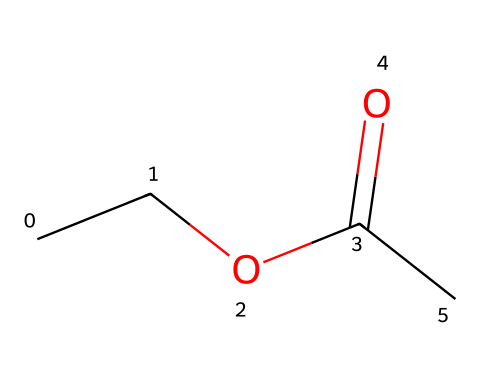what is the molecular formula of this compound? To find the molecular formula, we count the number of each type of atom in the SMILES representation. The structure indicates it contains 4 carbons (C), 8 hydrogens (H), and 2 oxygens (O), resulting in the molecular formula C4H8O2.
Answer: C4H8O2 how many carbon atoms are present in this chemical? By analyzing the SMILES representation, we see the part 'CCOC(=O)C', which includes four 'C' characters. Therefore, there are four carbon atoms in total.
Answer: 4 what type of functional group does this compound contain? The presence of the 'C(=O)' portion indicates a carbonyl functional group. Additionally, the 'C(=O)O' suggests the presence of a carboxylic acid functional group. Thus, this compound is an ester due to the 'COC' linked with a carbonyl.
Answer: ester how many hydrogen atoms are bonded to the carbon atoms in this compound? In the structure, each carbon atom typically bonds with enough hydrogens to fill its tetravalent nature. The breakdown shows that there are 8 hydrogen atoms in total bonded to the four carbon atoms, based on the overall connectivity in the structure.
Answer: 8 which part of this compound is responsible for the fruity aroma often associated with whisky? The ester functional group (indicated by 'COC') is known for contributing to fruity aromas. In whisky, this characteristic is often linked to esters formed during fermentation and aging.
Answer: ester is this compound likely to be volatile? Compounds with lower molecular weight and ester functional groups, such as this one, generally exhibit volatility due to their tendency to evaporate easily under standard conditions. Therefore, we can classify it as likely volatile.
Answer: likely volatile 